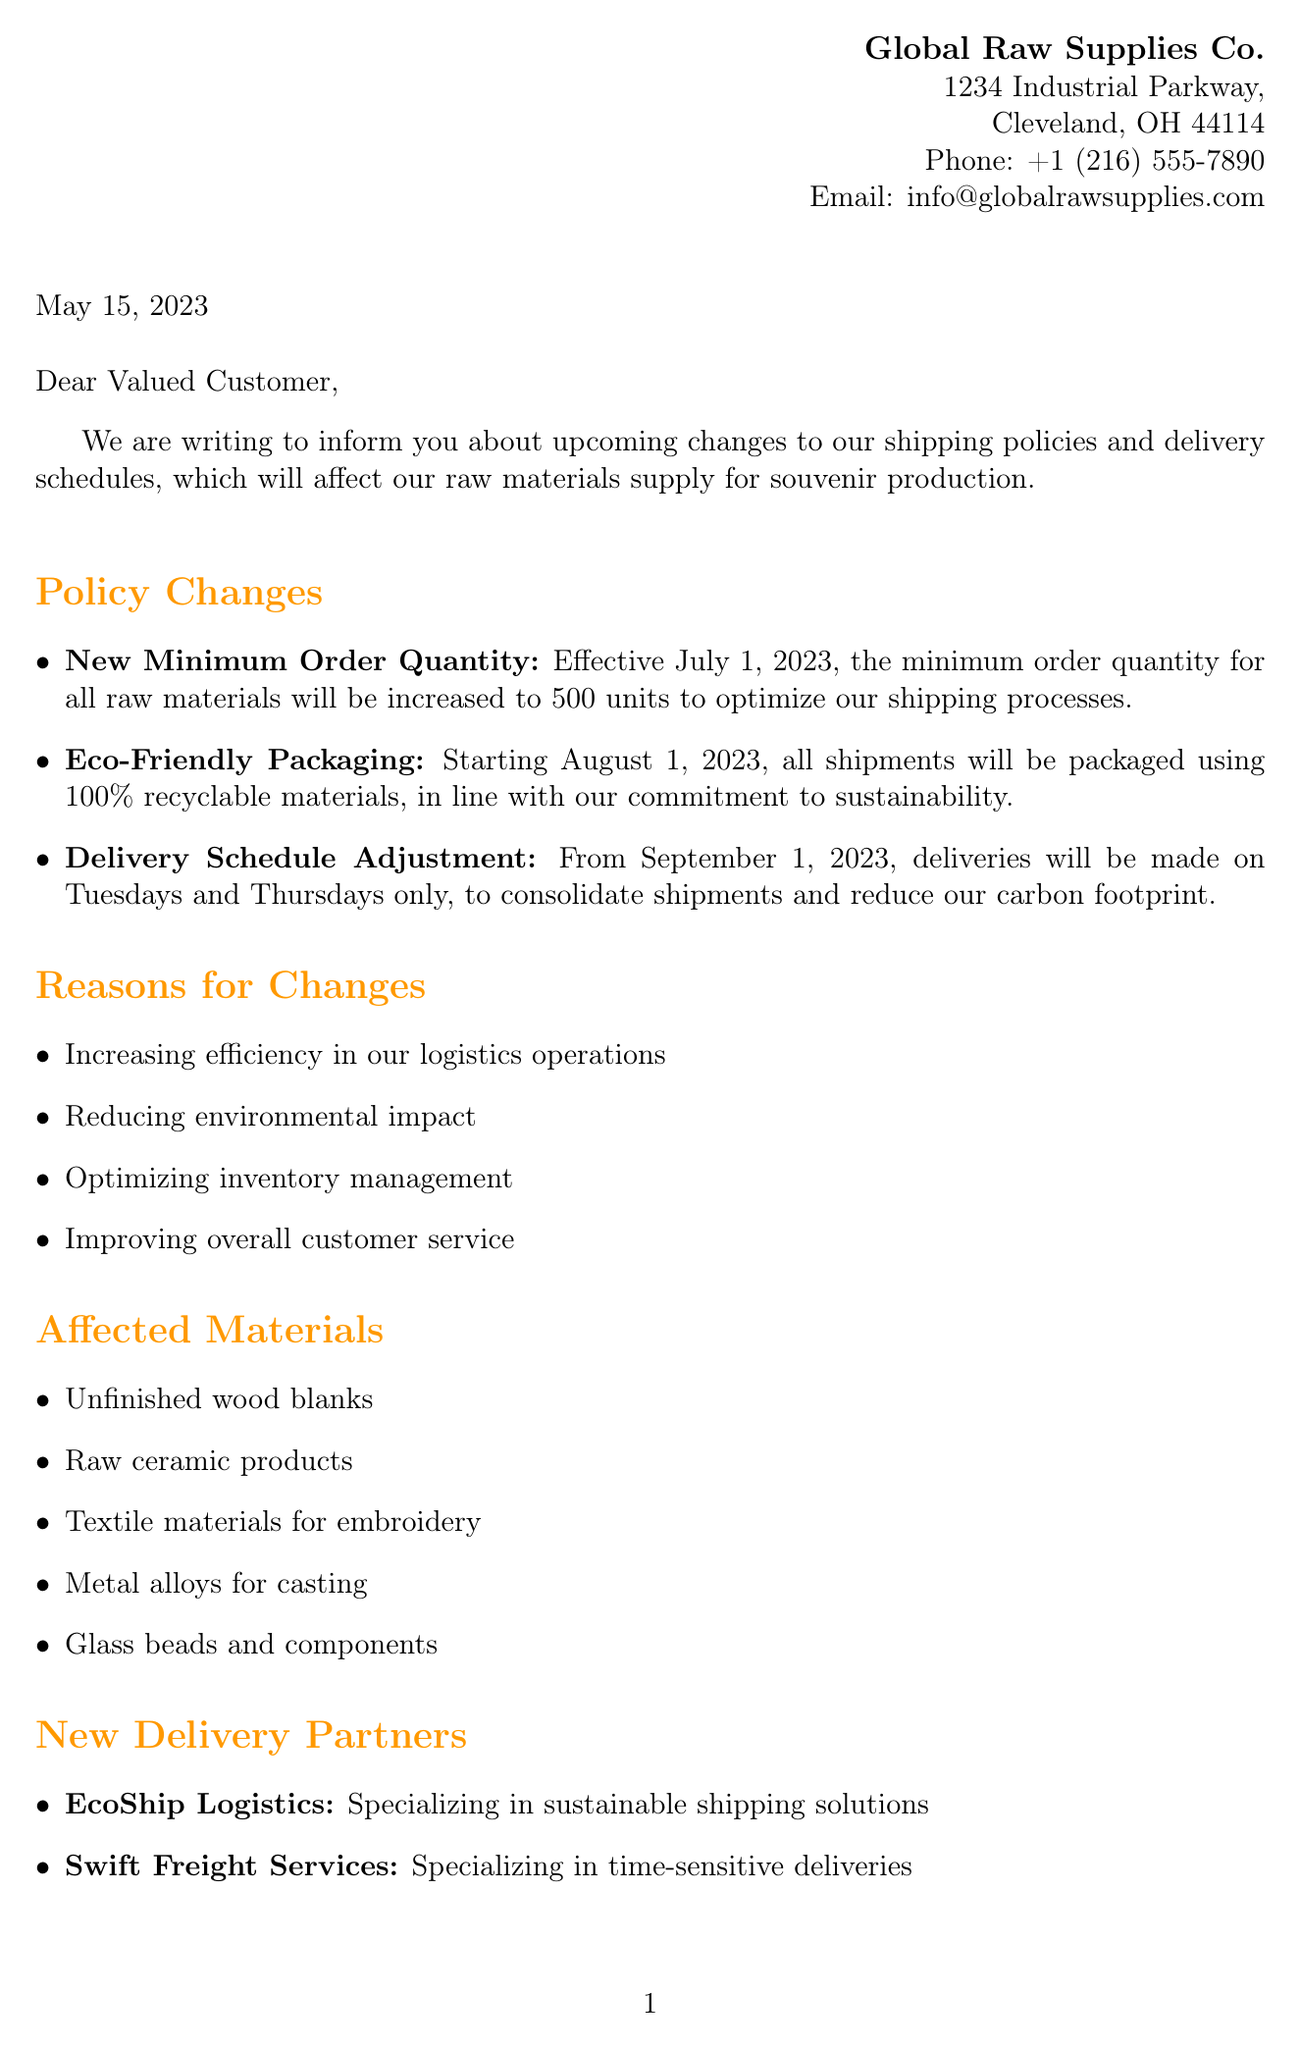what is the new minimum order quantity? The minimum order quantity for all raw materials will be increased to 500 units effective July 1, 2023.
Answer: 500 units when will eco-friendly packaging be implemented? Eco-friendly packaging will start being used for all shipments beginning on August 1, 2023.
Answer: August 1, 2023 who is the Customer Relations Manager? The Customer Relations Manager listed in the document is Sarah Johnson.
Answer: Sarah Johnson what are the new delivery days? Deliveries will be made on Tuesdays and Thursdays only from September 1, 2023.
Answer: Tuesdays and Thursdays what is the transition period for the new policies? The transition period during which both old and new policies will be honored is from June 15, 2023, to September 30, 2023.
Answer: June 15 to September 30, 2023 why are the changes being made? The changes are being made to increase efficiency, reduce environmental impact, optimize inventory management, and improve customer service.
Answer: Increase efficiency, reduce environmental impact, optimize inventory management, improve customer service which company specializes in sustainable shipping solutions? The company that specializes in sustainable shipping solutions is EcoShip Logistics.
Answer: EcoShip Logistics what is the phone number for customer support? The phone number for customer support listed in the document is +1 (216) 555-7891.
Answer: +1 (216) 555-7891 